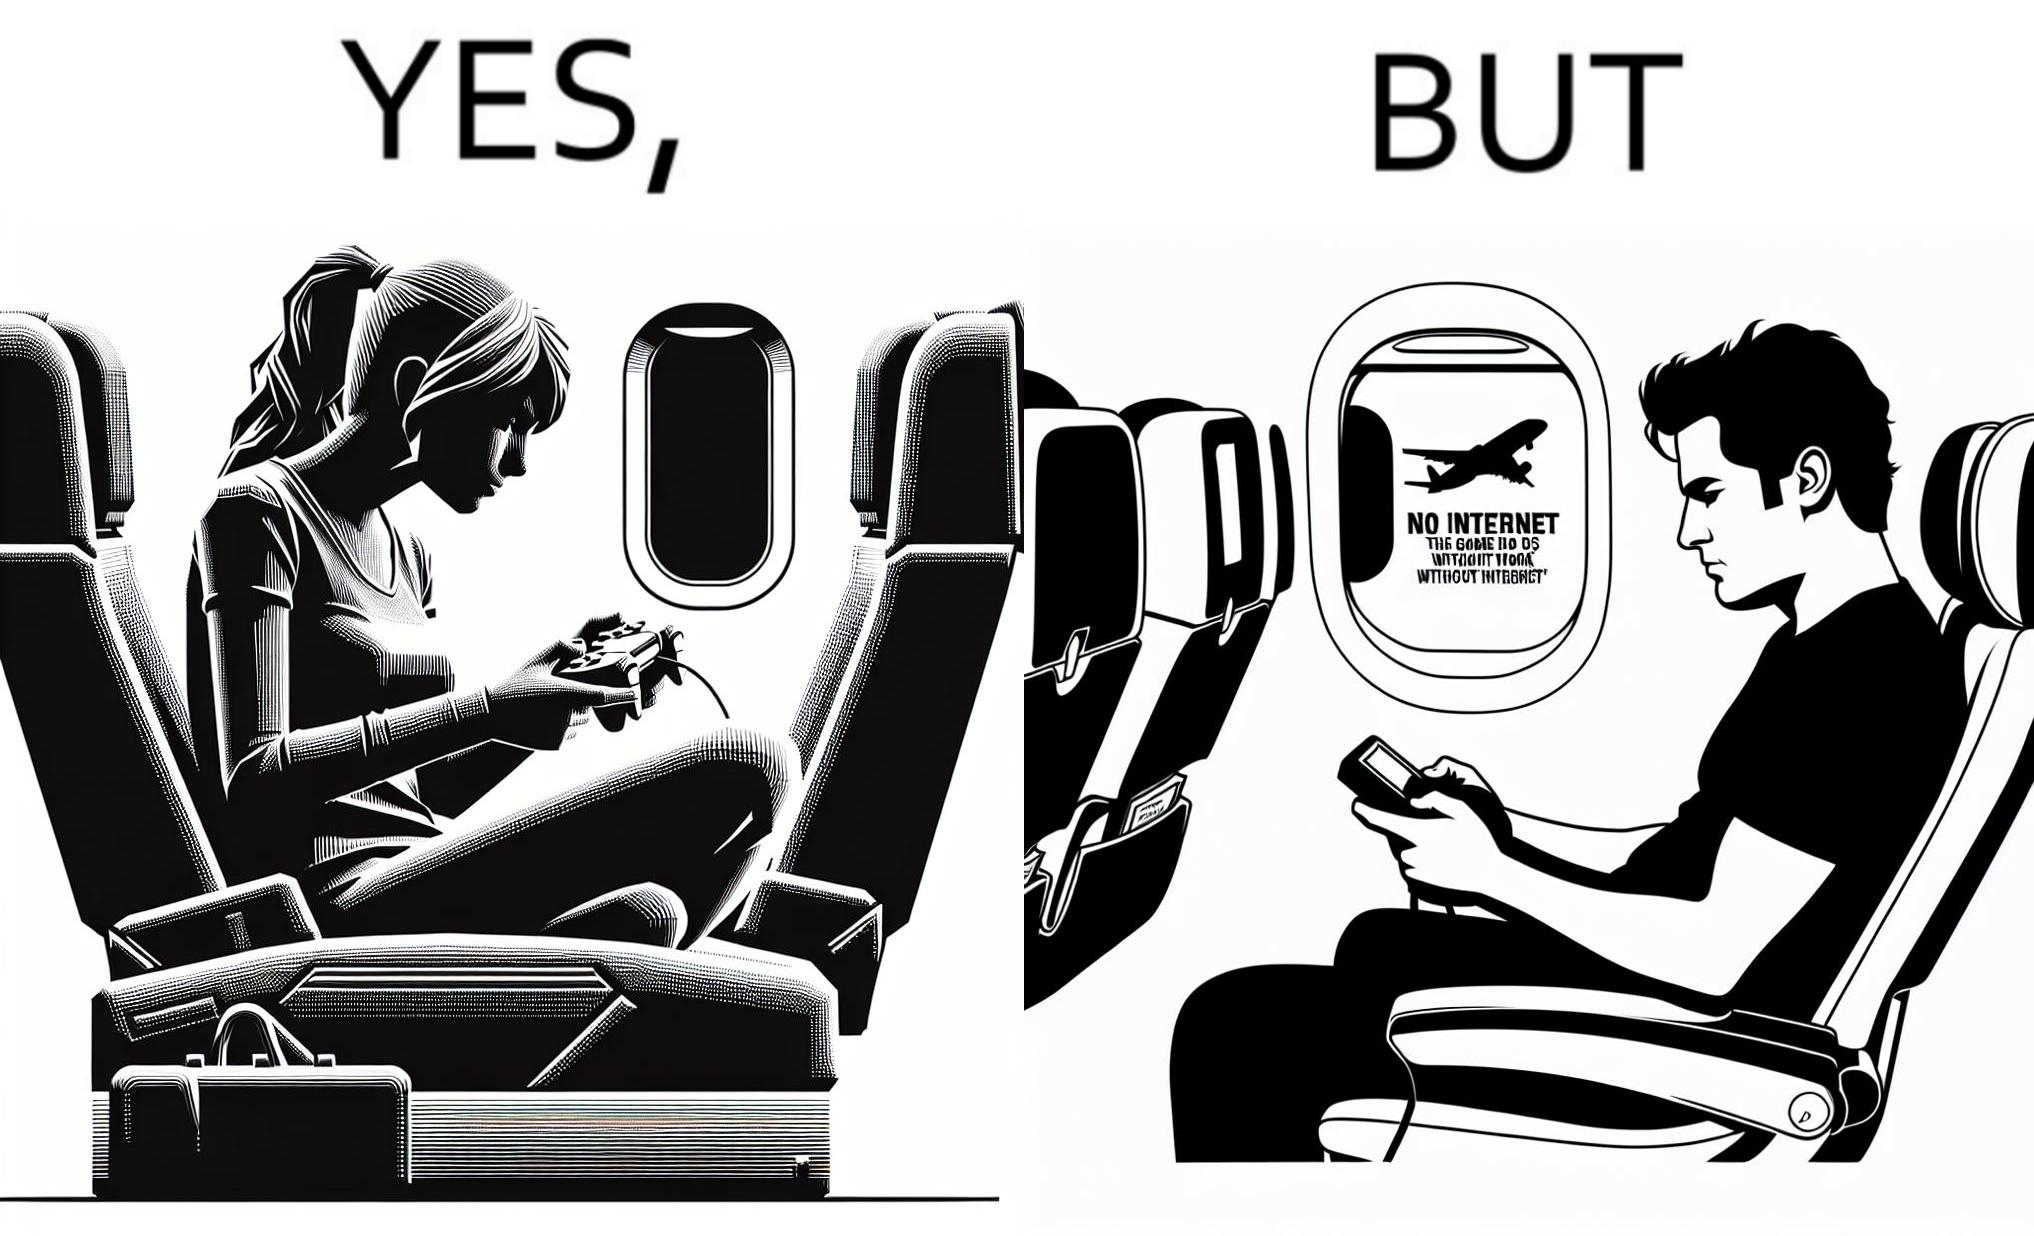Describe the satirical element in this image. The image is ironic, as the person is holding the game console to play a game during the flight. However, the person is unable to play the game, as the game requires internet (as is the case with many modern games), and internet is unavailable in many lights. 